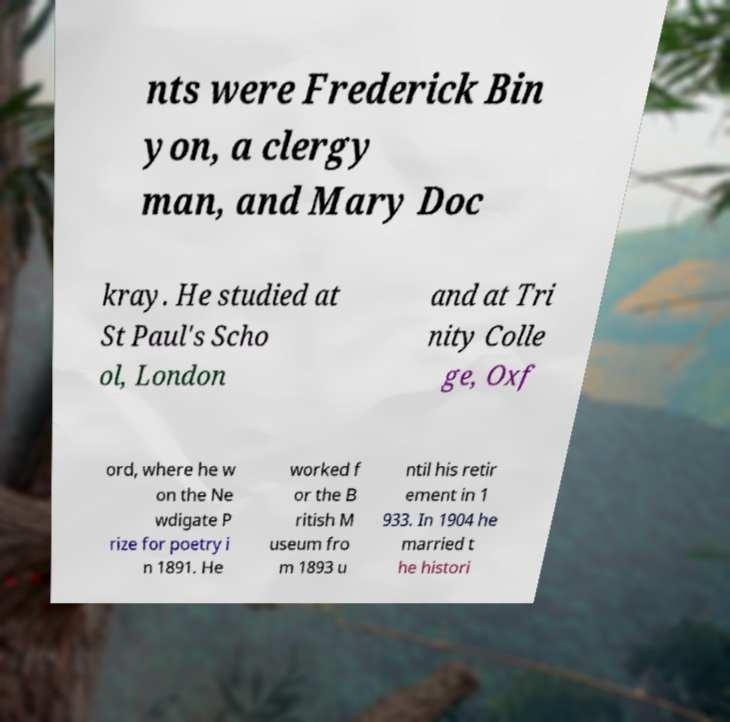For documentation purposes, I need the text within this image transcribed. Could you provide that? nts were Frederick Bin yon, a clergy man, and Mary Doc kray. He studied at St Paul's Scho ol, London and at Tri nity Colle ge, Oxf ord, where he w on the Ne wdigate P rize for poetry i n 1891. He worked f or the B ritish M useum fro m 1893 u ntil his retir ement in 1 933. In 1904 he married t he histori 